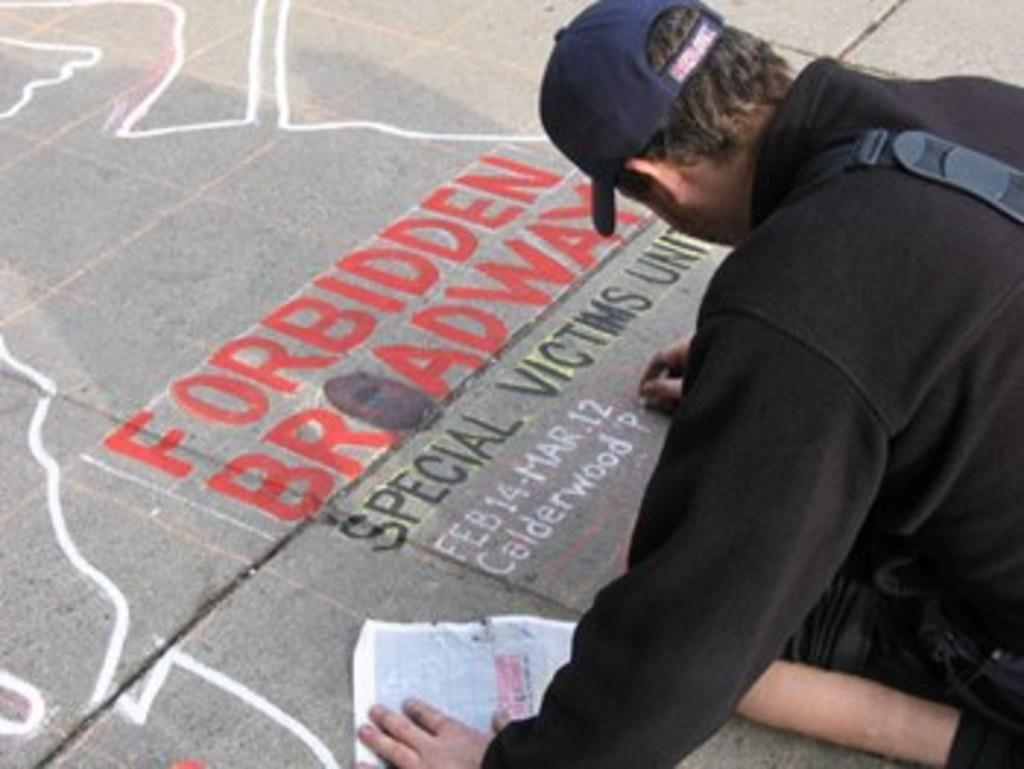Who is present in the image? There is a man in the image. What is the man wearing on his head? The man is wearing a cap. What is the man doing in the image? The man is writing something on the ground. What is on the ground besides the man? There is a paper and an object on the ground. What type of pickle is the man holding in the image? There is no pickle present in the image. What type of pleasure does the man derive from writing on the ground? The image does not provide information about the man's emotions or motivations, so we cannot determine the type of pleasure he might derive from writing on the ground. 